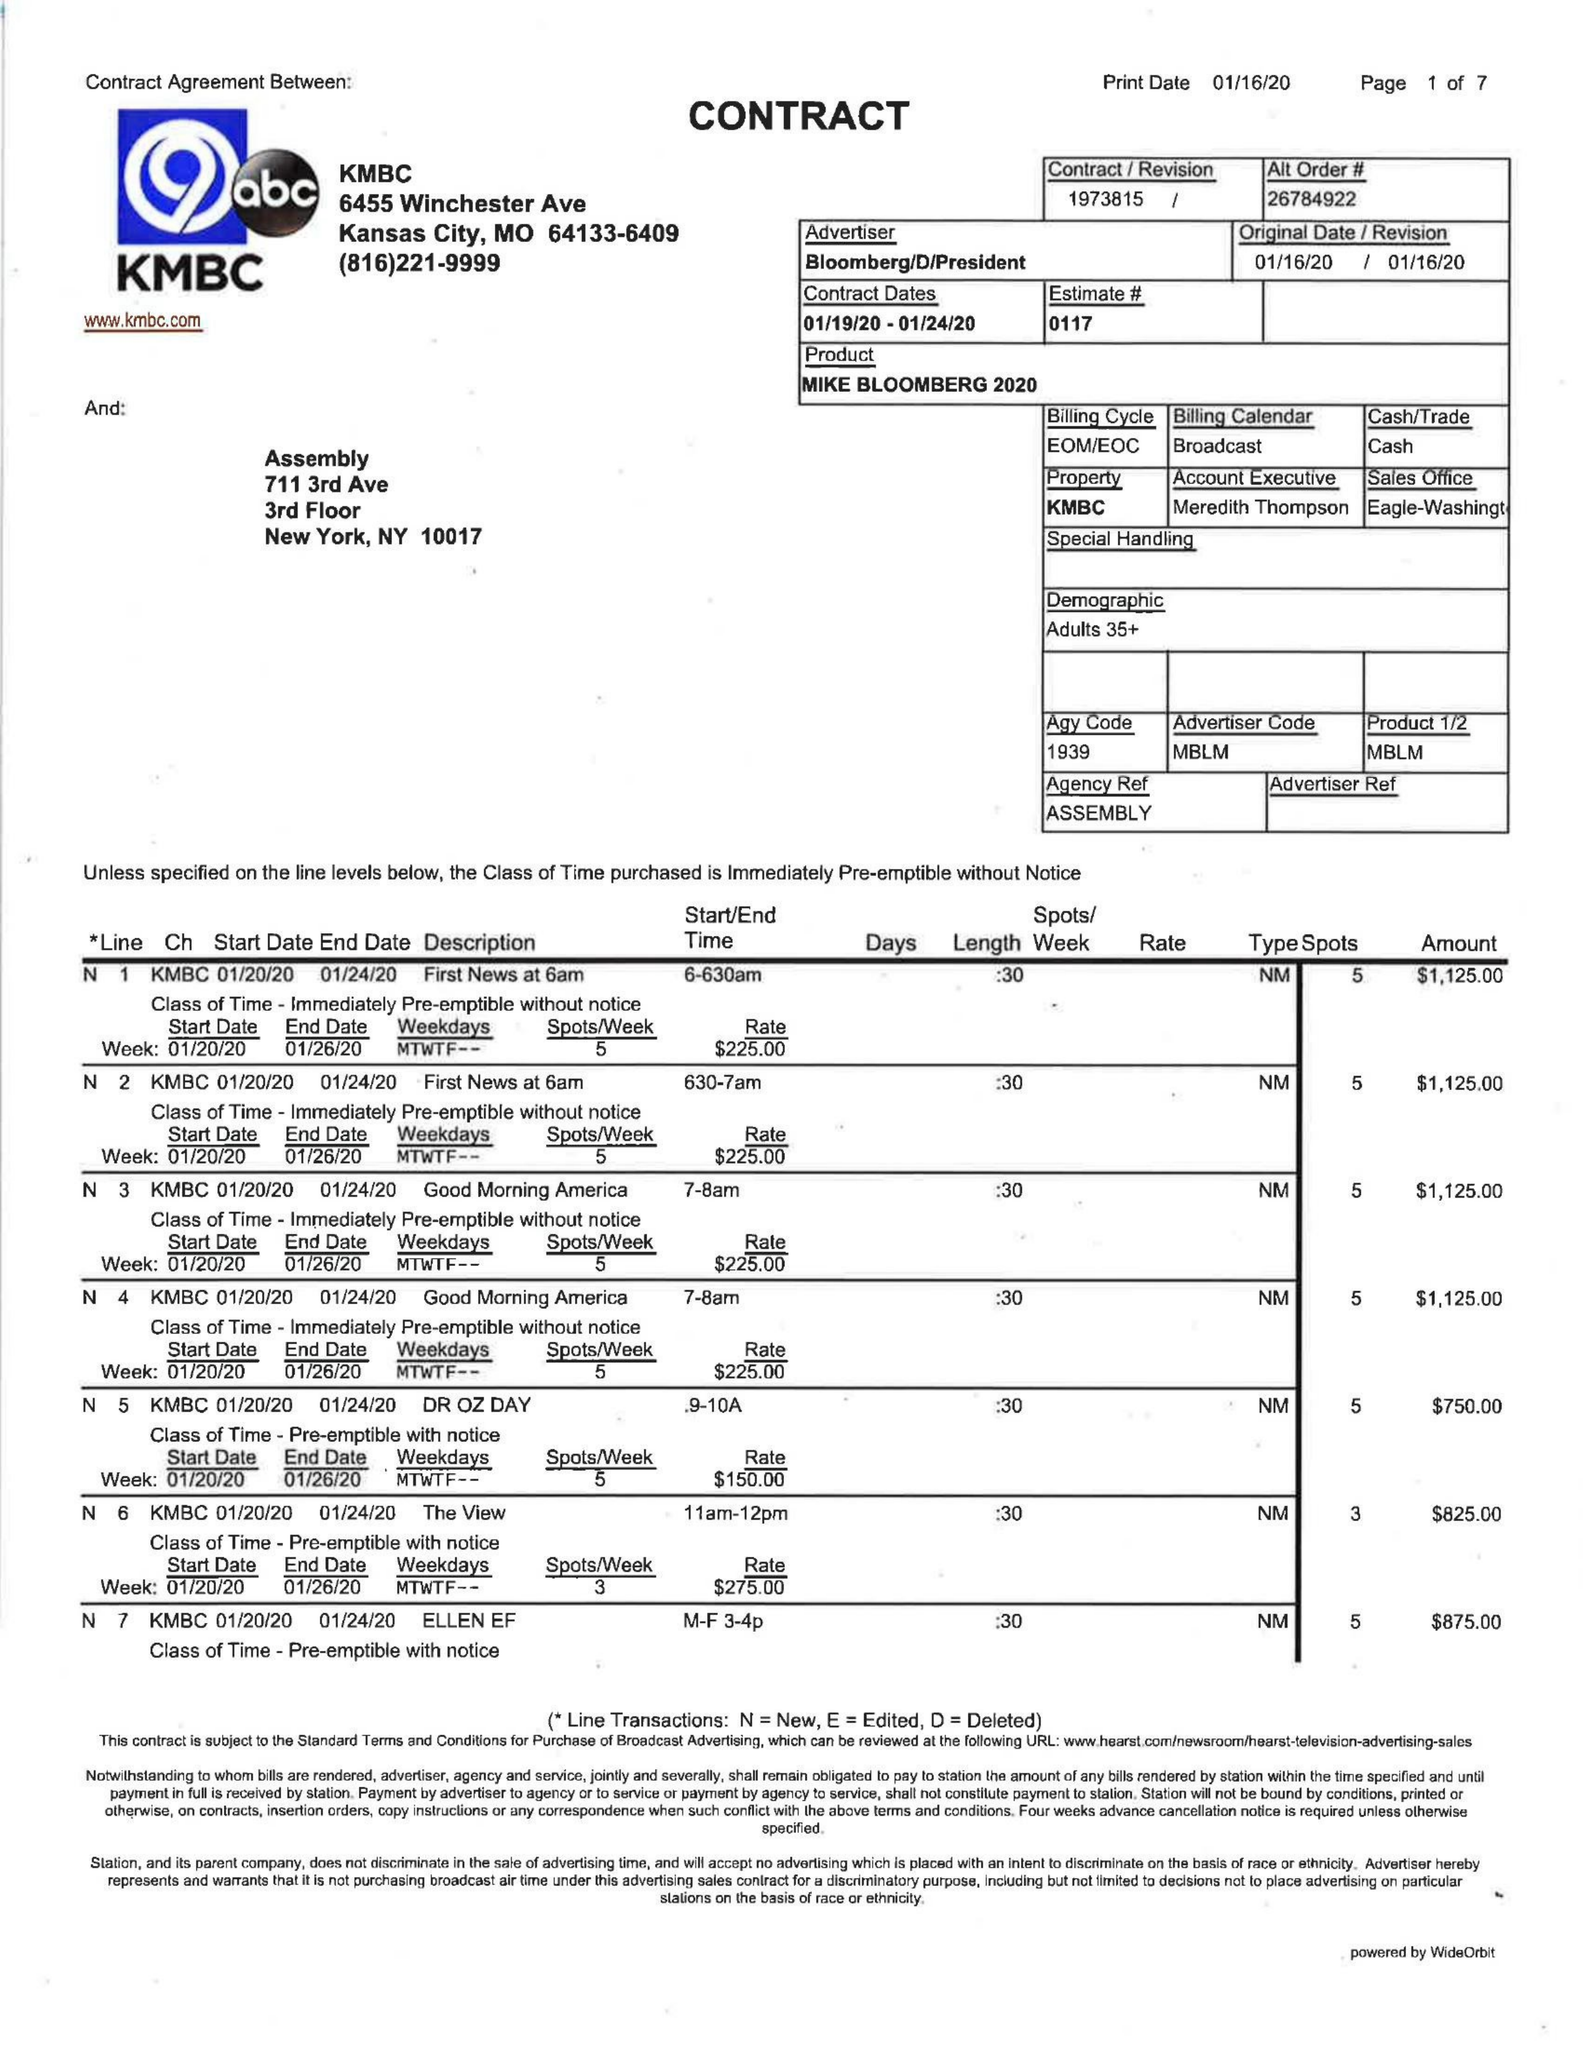What is the value for the flight_to?
Answer the question using a single word or phrase. 01/24/20 